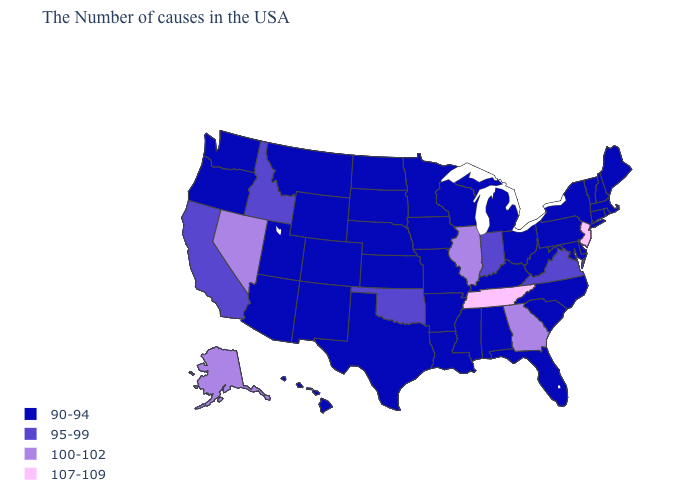Name the states that have a value in the range 100-102?
Give a very brief answer. Georgia, Illinois, Nevada, Alaska. Name the states that have a value in the range 95-99?
Quick response, please. Virginia, Indiana, Oklahoma, Idaho, California. Among the states that border Montana , which have the highest value?
Give a very brief answer. Idaho. Which states have the lowest value in the MidWest?
Short answer required. Ohio, Michigan, Wisconsin, Missouri, Minnesota, Iowa, Kansas, Nebraska, South Dakota, North Dakota. What is the lowest value in states that border New Mexico?
Short answer required. 90-94. What is the highest value in states that border New Mexico?
Be succinct. 95-99. Is the legend a continuous bar?
Quick response, please. No. What is the lowest value in the South?
Give a very brief answer. 90-94. Does North Dakota have the highest value in the MidWest?
Concise answer only. No. What is the value of Louisiana?
Be succinct. 90-94. Does North Carolina have the same value as North Dakota?
Give a very brief answer. Yes. Which states have the highest value in the USA?
Be succinct. New Jersey, Tennessee. Which states have the lowest value in the USA?
Give a very brief answer. Maine, Massachusetts, Rhode Island, New Hampshire, Vermont, Connecticut, New York, Delaware, Maryland, Pennsylvania, North Carolina, South Carolina, West Virginia, Ohio, Florida, Michigan, Kentucky, Alabama, Wisconsin, Mississippi, Louisiana, Missouri, Arkansas, Minnesota, Iowa, Kansas, Nebraska, Texas, South Dakota, North Dakota, Wyoming, Colorado, New Mexico, Utah, Montana, Arizona, Washington, Oregon, Hawaii. Does Georgia have the lowest value in the USA?
Be succinct. No. What is the value of Michigan?
Keep it brief. 90-94. 